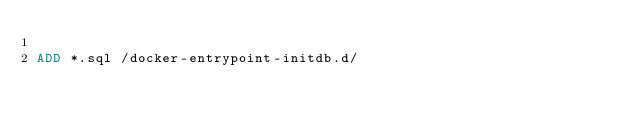Convert code to text. <code><loc_0><loc_0><loc_500><loc_500><_Dockerfile_>
ADD *.sql /docker-entrypoint-initdb.d/
</code> 